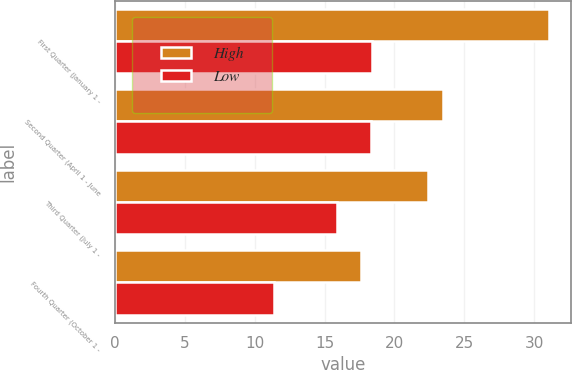Convert chart. <chart><loc_0><loc_0><loc_500><loc_500><stacked_bar_chart><ecel><fcel>First Quarter (January 1 -<fcel>Second Quarter (April 1 - June<fcel>Third Quarter (July 1 -<fcel>Fourth Quarter (October 1 -<nl><fcel>High<fcel>31.06<fcel>23.46<fcel>22.37<fcel>17.61<nl><fcel>Low<fcel>18.4<fcel>18.35<fcel>15.92<fcel>11.4<nl></chart> 